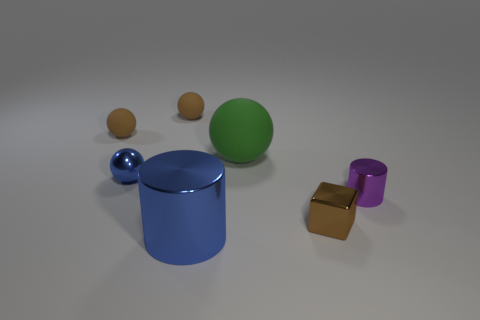There is a tiny purple metal thing; is it the same shape as the blue thing in front of the metal ball?
Provide a succinct answer. Yes. There is a ball on the right side of the big object in front of the small metal object that is left of the brown shiny block; what is its material?
Provide a succinct answer. Rubber. Do the metallic thing that is on the left side of the large shiny thing and the large rubber thing have the same shape?
Ensure brevity in your answer.  Yes. The large rubber object that is the same shape as the tiny blue object is what color?
Provide a succinct answer. Green. Is there any other thing that has the same shape as the green matte thing?
Your response must be concise. Yes. The other metallic thing that is the same shape as the tiny purple metal object is what size?
Ensure brevity in your answer.  Large. How many things are the same color as the cube?
Offer a terse response. 2. Is the shape of the big rubber thing the same as the small blue metal thing?
Your answer should be compact. Yes. What is the size of the cylinder that is on the right side of the metallic cylinder to the left of the big green ball?
Keep it short and to the point. Small. Is there a blue metal cylinder that has the same size as the green matte thing?
Give a very brief answer. Yes. 